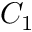Convert formula to latex. <formula><loc_0><loc_0><loc_500><loc_500>C _ { 1 }</formula> 